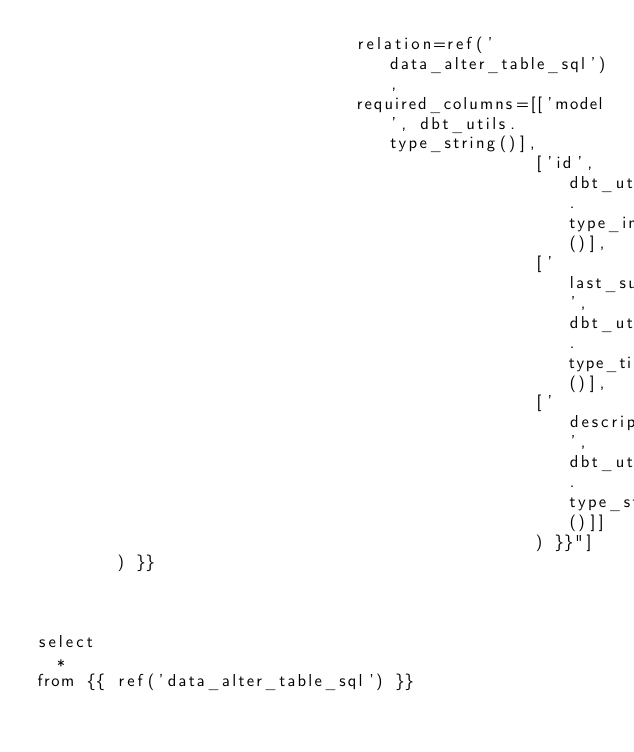Convert code to text. <code><loc_0><loc_0><loc_500><loc_500><_SQL_>                                relation=ref('data_alter_table_sql'),
                                required_columns=[['model', dbt_utils.type_string()],
                                                  ['id', dbt_utils.type_int()],
                                                  ['last_success', dbt_utils.type_timestamp()],
                                                  ['description', dbt_utils.type_string()]]
                                                  ) }}"]
        ) }}



select
  *
from {{ ref('data_alter_table_sql') }}
</code> 